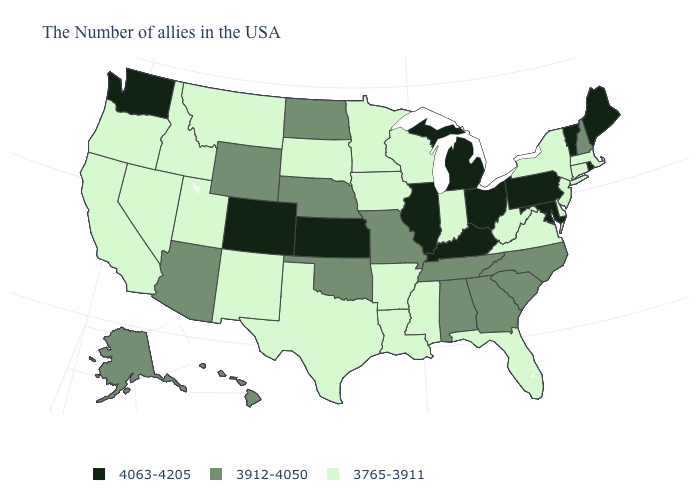Among the states that border Washington , which have the lowest value?
Short answer required. Idaho, Oregon. What is the value of Oregon?
Write a very short answer. 3765-3911. What is the value of Louisiana?
Keep it brief. 3765-3911. What is the highest value in states that border New York?
Keep it brief. 4063-4205. What is the value of Mississippi?
Quick response, please. 3765-3911. Name the states that have a value in the range 4063-4205?
Give a very brief answer. Maine, Rhode Island, Vermont, Maryland, Pennsylvania, Ohio, Michigan, Kentucky, Illinois, Kansas, Colorado, Washington. What is the value of Colorado?
Quick response, please. 4063-4205. What is the value of Indiana?
Short answer required. 3765-3911. What is the lowest value in the USA?
Short answer required. 3765-3911. Name the states that have a value in the range 4063-4205?
Short answer required. Maine, Rhode Island, Vermont, Maryland, Pennsylvania, Ohio, Michigan, Kentucky, Illinois, Kansas, Colorado, Washington. Name the states that have a value in the range 3912-4050?
Concise answer only. New Hampshire, North Carolina, South Carolina, Georgia, Alabama, Tennessee, Missouri, Nebraska, Oklahoma, North Dakota, Wyoming, Arizona, Alaska, Hawaii. What is the value of Oregon?
Give a very brief answer. 3765-3911. What is the value of Florida?
Answer briefly. 3765-3911. Does the first symbol in the legend represent the smallest category?
Keep it brief. No. Name the states that have a value in the range 3765-3911?
Quick response, please. Massachusetts, Connecticut, New York, New Jersey, Delaware, Virginia, West Virginia, Florida, Indiana, Wisconsin, Mississippi, Louisiana, Arkansas, Minnesota, Iowa, Texas, South Dakota, New Mexico, Utah, Montana, Idaho, Nevada, California, Oregon. 